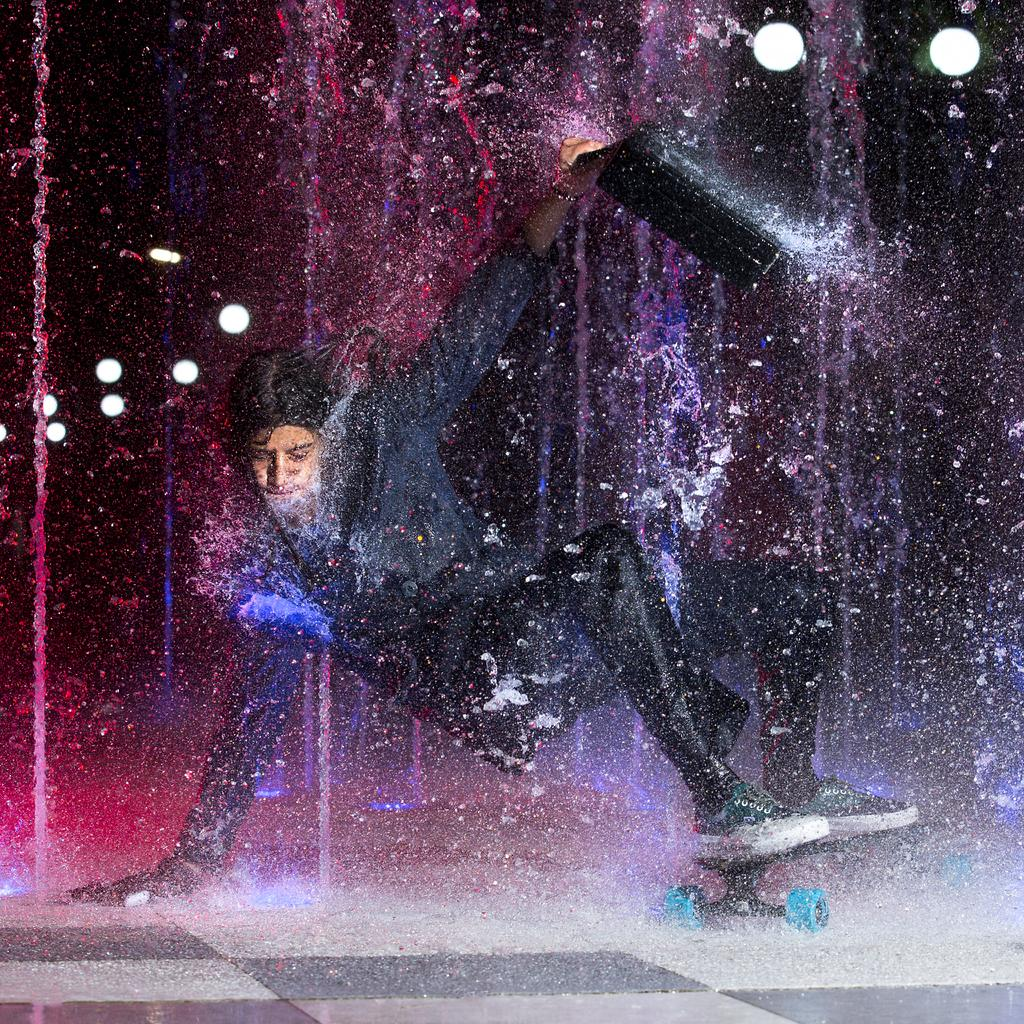What is happening in the image? There is a person in the image performing a somersault. Where is the somersault taking place? The somersault is taking place on a dance floor. What can be seen in the background of the image? There are lights visible in the background of the image. What type of drink is the horse holding after the somersault? There is no horse or drink present in the image. 